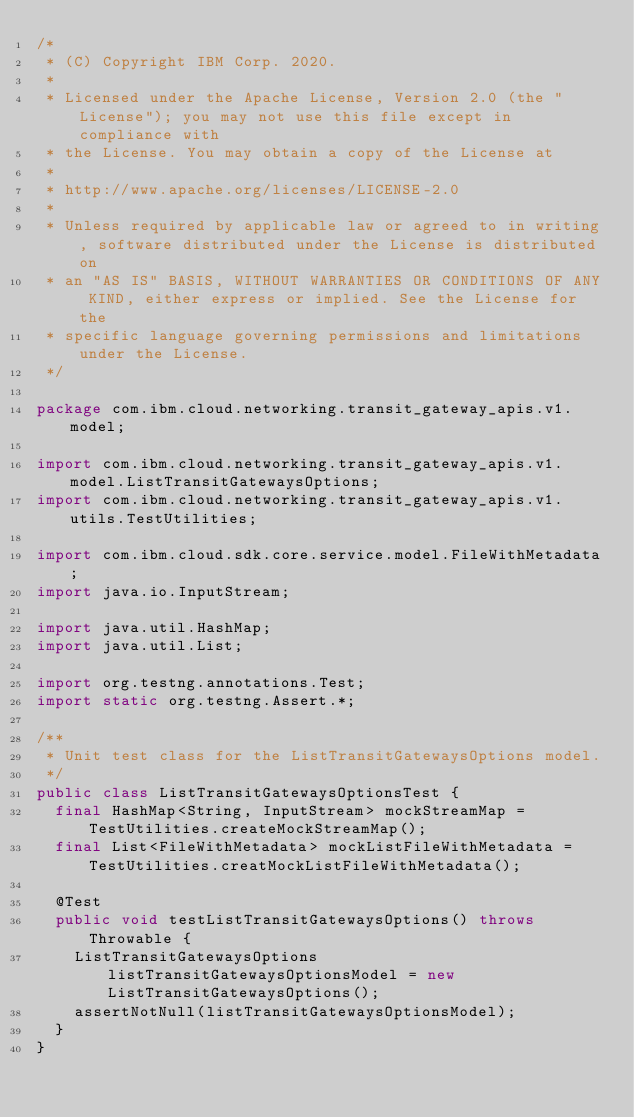<code> <loc_0><loc_0><loc_500><loc_500><_Java_>/*
 * (C) Copyright IBM Corp. 2020.
 *
 * Licensed under the Apache License, Version 2.0 (the "License"); you may not use this file except in compliance with
 * the License. You may obtain a copy of the License at
 *
 * http://www.apache.org/licenses/LICENSE-2.0
 *
 * Unless required by applicable law or agreed to in writing, software distributed under the License is distributed on
 * an "AS IS" BASIS, WITHOUT WARRANTIES OR CONDITIONS OF ANY KIND, either express or implied. See the License for the
 * specific language governing permissions and limitations under the License.
 */

package com.ibm.cloud.networking.transit_gateway_apis.v1.model;

import com.ibm.cloud.networking.transit_gateway_apis.v1.model.ListTransitGatewaysOptions;
import com.ibm.cloud.networking.transit_gateway_apis.v1.utils.TestUtilities;

import com.ibm.cloud.sdk.core.service.model.FileWithMetadata;
import java.io.InputStream;

import java.util.HashMap;
import java.util.List;

import org.testng.annotations.Test;
import static org.testng.Assert.*;

/**
 * Unit test class for the ListTransitGatewaysOptions model.
 */
public class ListTransitGatewaysOptionsTest {
  final HashMap<String, InputStream> mockStreamMap = TestUtilities.createMockStreamMap();
  final List<FileWithMetadata> mockListFileWithMetadata = TestUtilities.creatMockListFileWithMetadata();

  @Test
  public void testListTransitGatewaysOptions() throws Throwable {
    ListTransitGatewaysOptions listTransitGatewaysOptionsModel = new ListTransitGatewaysOptions();
    assertNotNull(listTransitGatewaysOptionsModel);
  }
}</code> 